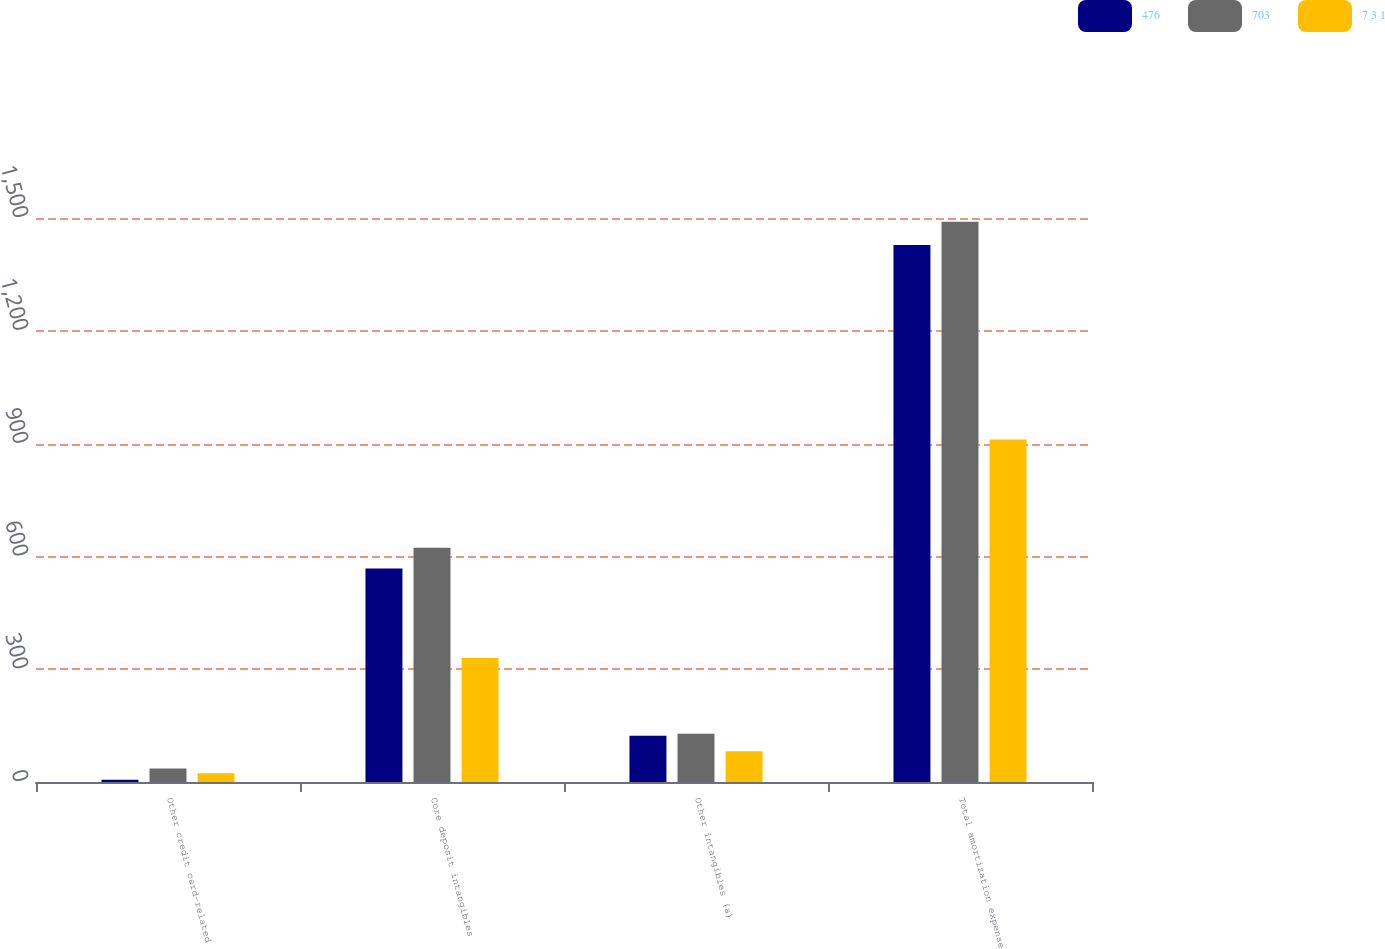Convert chart to OTSL. <chart><loc_0><loc_0><loc_500><loc_500><stacked_bar_chart><ecel><fcel>Other credit card-related<fcel>Core deposit intangibles<fcel>Other intangibles (a)<fcel>Total amortization expense<nl><fcel>476<fcel>6<fcel>568<fcel>123<fcel>1428<nl><fcel>703<fcel>36<fcel>623<fcel>128<fcel>1490<nl><fcel>7 3 1<fcel>23<fcel>330<fcel>82<fcel>911<nl></chart> 